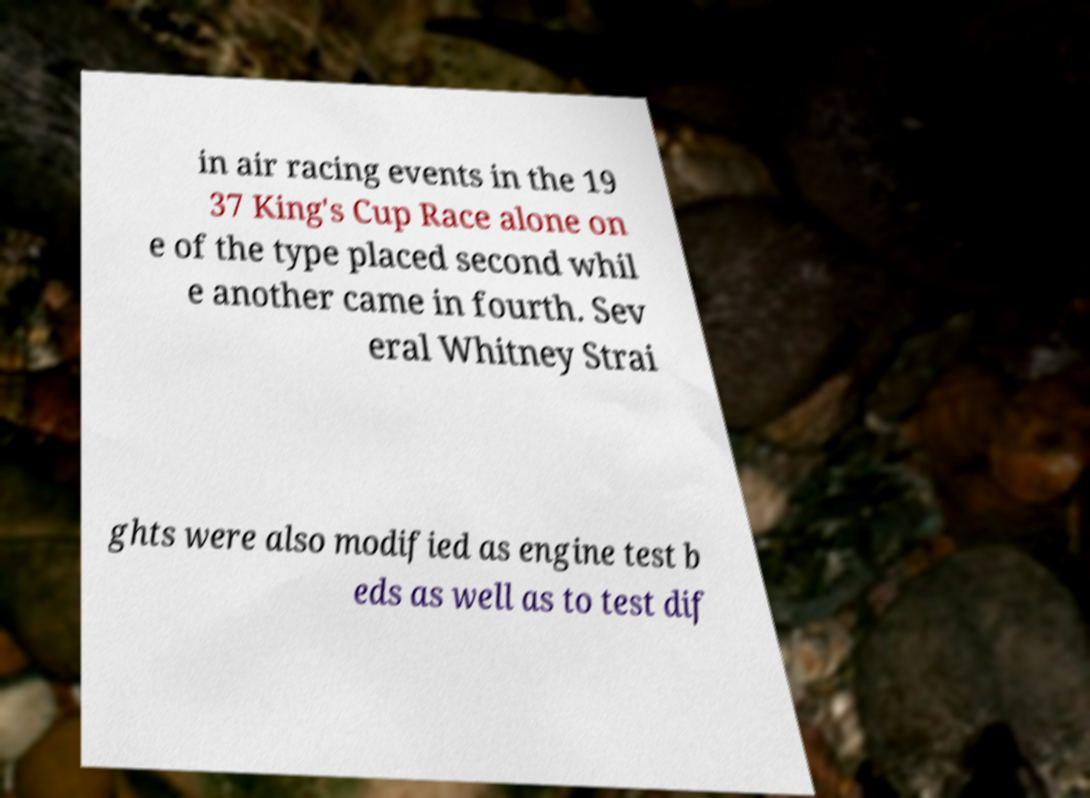Please read and relay the text visible in this image. What does it say? in air racing events in the 19 37 King's Cup Race alone on e of the type placed second whil e another came in fourth. Sev eral Whitney Strai ghts were also modified as engine test b eds as well as to test dif 